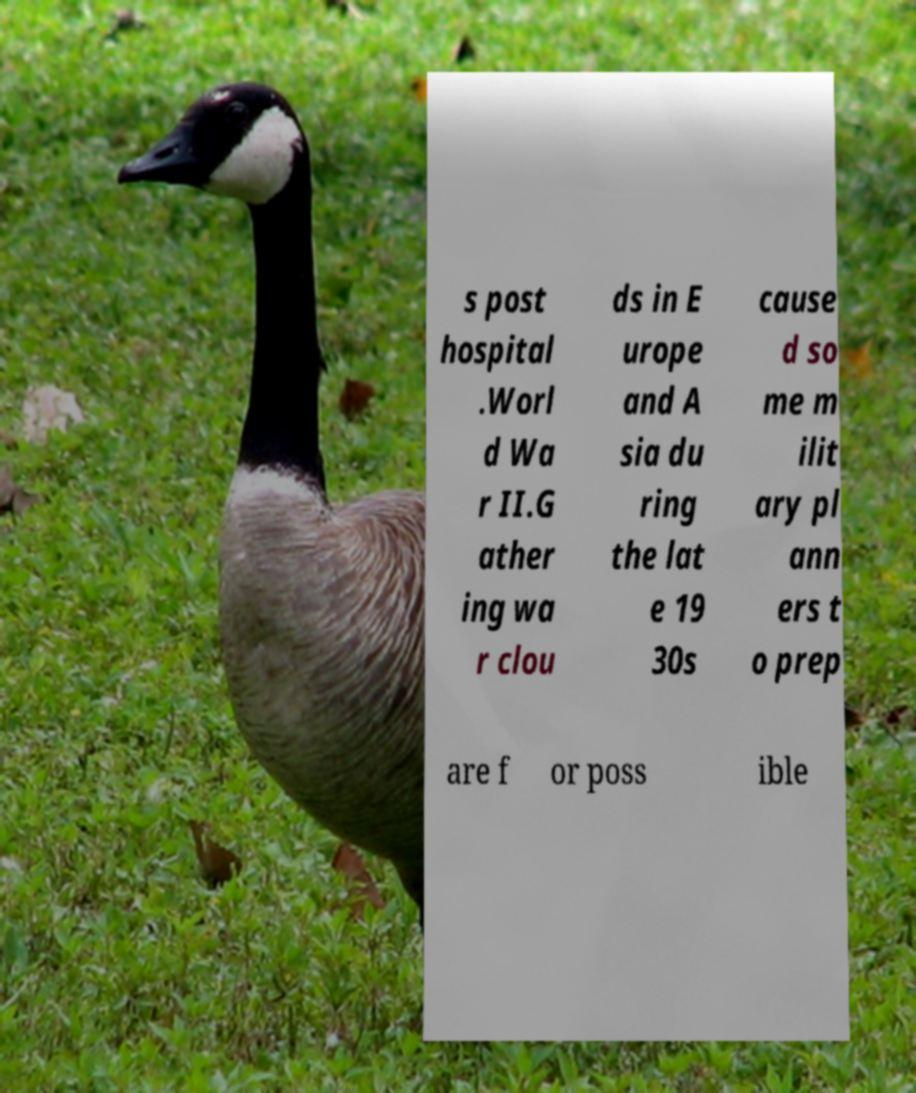What messages or text are displayed in this image? I need them in a readable, typed format. s post hospital .Worl d Wa r II.G ather ing wa r clou ds in E urope and A sia du ring the lat e 19 30s cause d so me m ilit ary pl ann ers t o prep are f or poss ible 